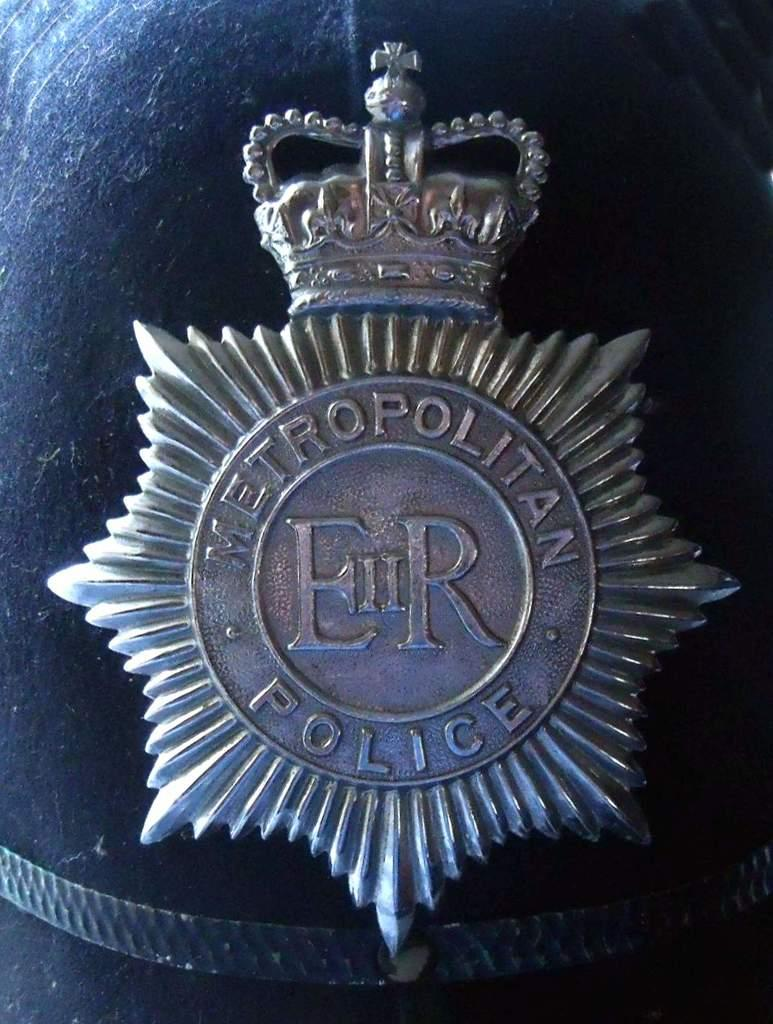Provide a one-sentence caption for the provided image. A badge for the Metropolitan police department, with a crown on the top of it. 